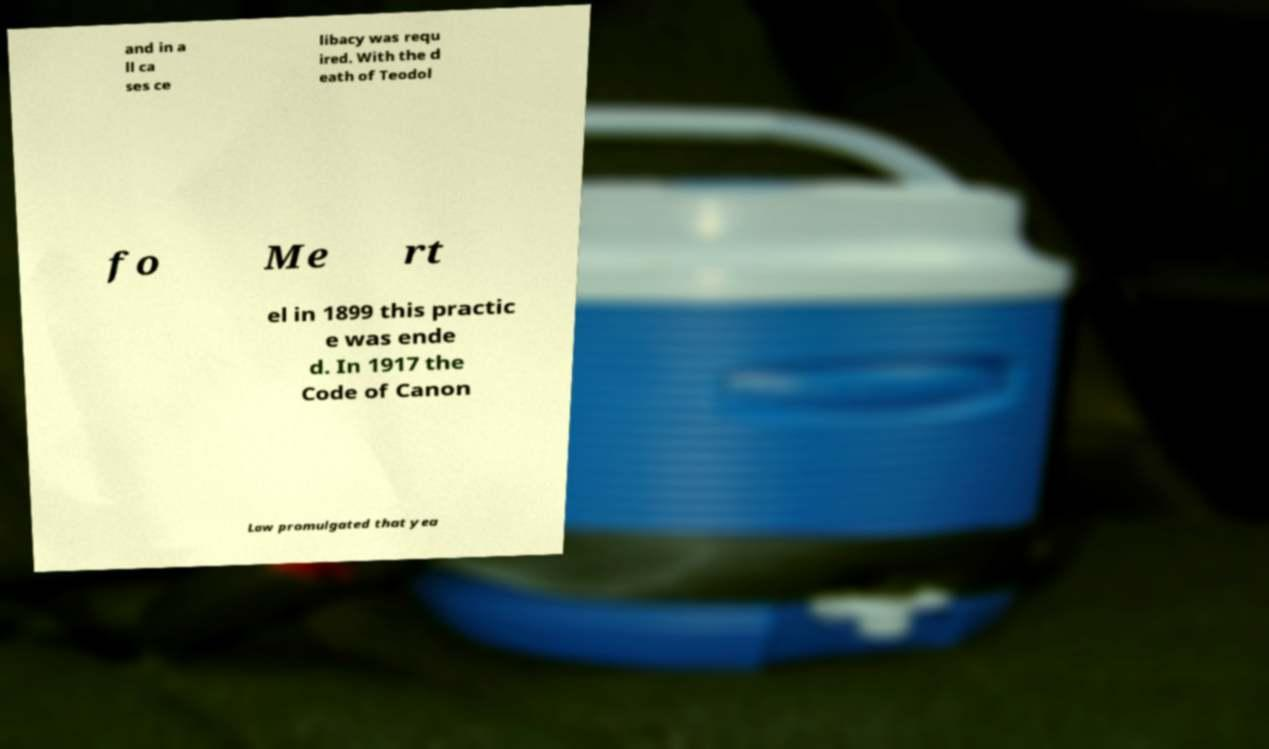For documentation purposes, I need the text within this image transcribed. Could you provide that? and in a ll ca ses ce libacy was requ ired. With the d eath of Teodol fo Me rt el in 1899 this practic e was ende d. In 1917 the Code of Canon Law promulgated that yea 